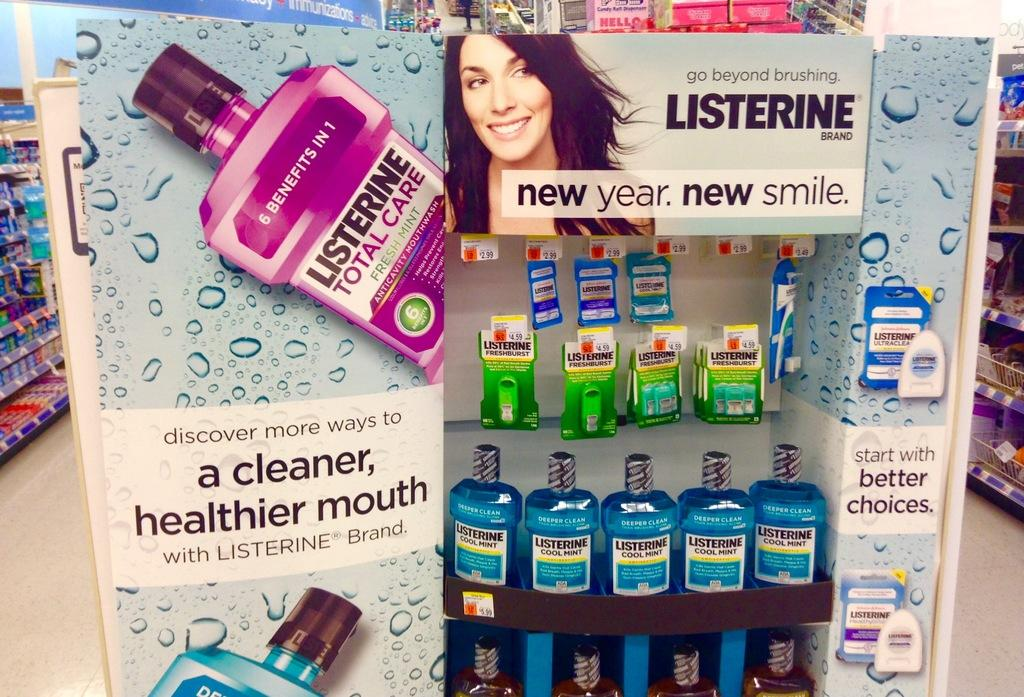<image>
Offer a succinct explanation of the picture presented. A Listerine ad shows a woman smiling and a bottle of the product. 